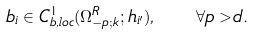<formula> <loc_0><loc_0><loc_500><loc_500>b _ { i } \in C _ { b , l o c } ^ { 1 } ( \Omega _ { - p ; k } ^ { R } ; h _ { i ^ { \prime } } ) , \quad \forall p > d .</formula> 